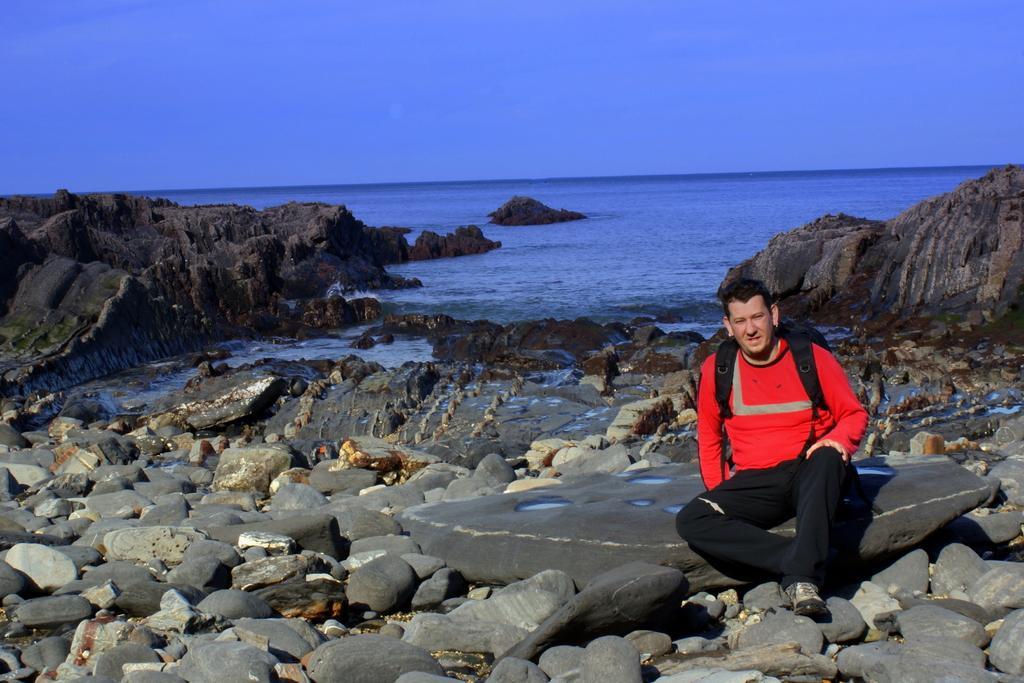How would you summarize this image in a sentence or two? In this image in the front there are stones. In the center there is a man sitting wearing a bag which is black in colour. In the background there is an ocean. 